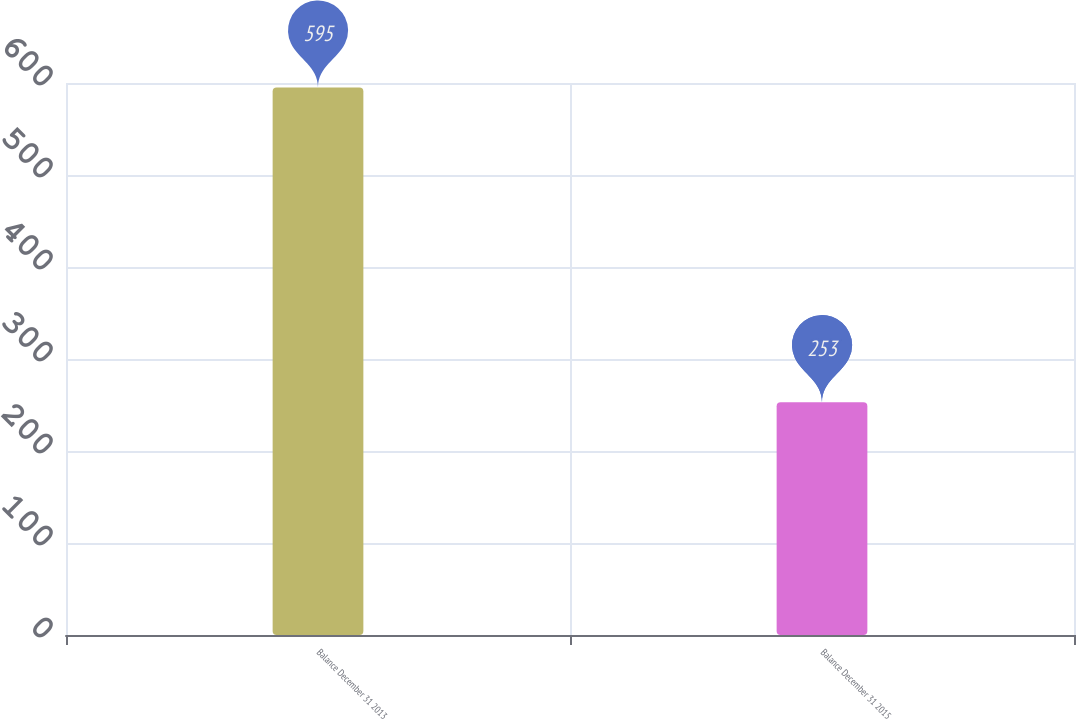Convert chart to OTSL. <chart><loc_0><loc_0><loc_500><loc_500><bar_chart><fcel>Balance December 31 2013<fcel>Balance December 31 2015<nl><fcel>595<fcel>253<nl></chart> 